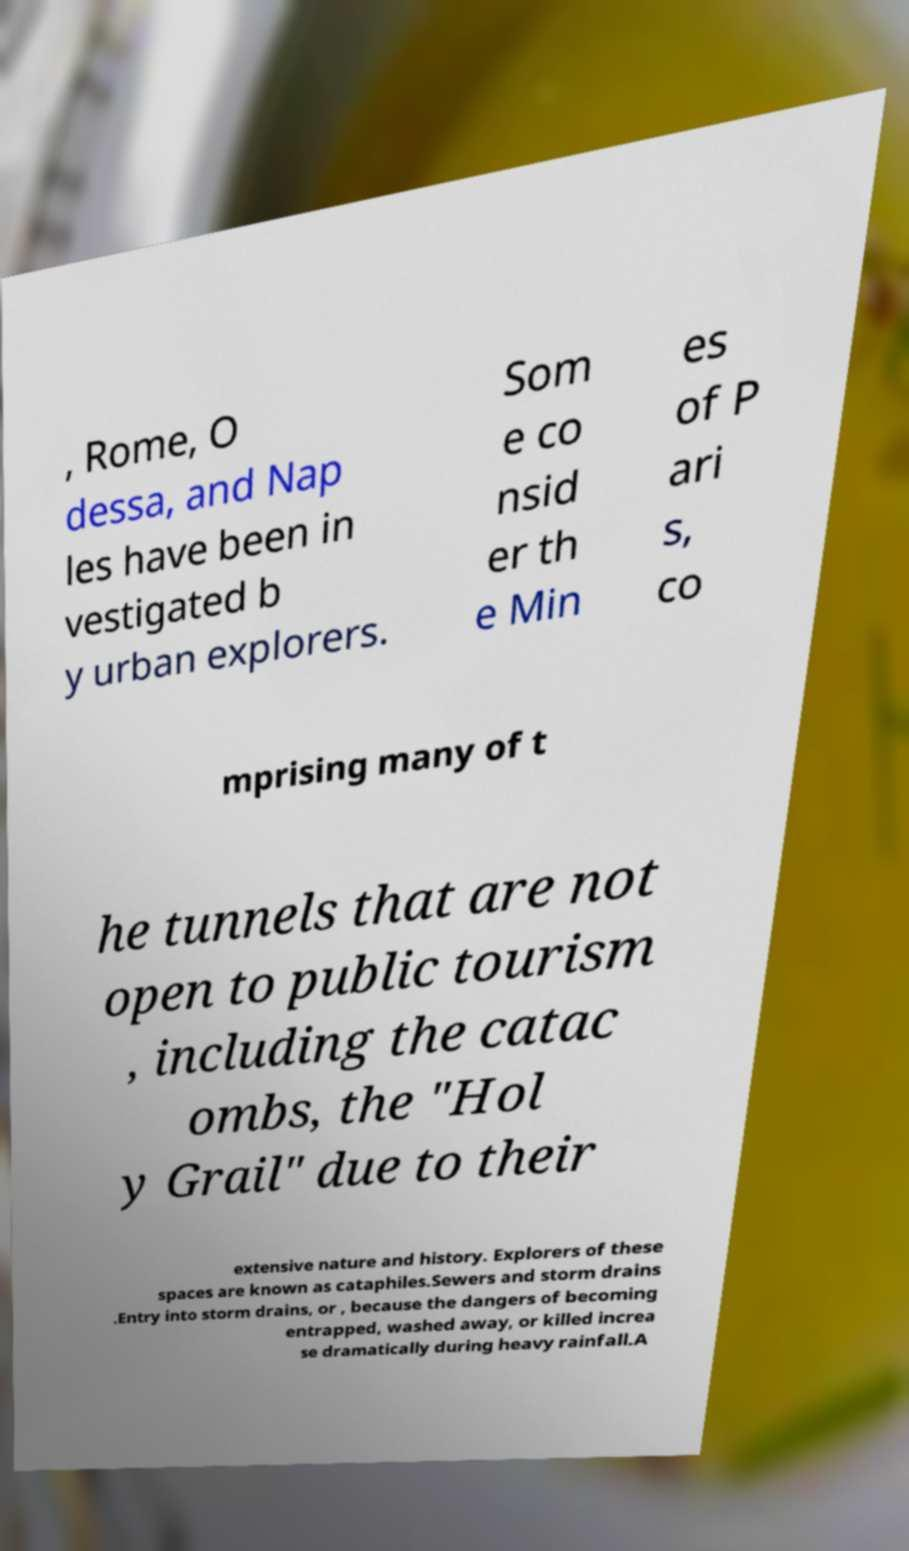Please read and relay the text visible in this image. What does it say? , Rome, O dessa, and Nap les have been in vestigated b y urban explorers. Som e co nsid er th e Min es of P ari s, co mprising many of t he tunnels that are not open to public tourism , including the catac ombs, the "Hol y Grail" due to their extensive nature and history. Explorers of these spaces are known as cataphiles.Sewers and storm drains .Entry into storm drains, or , because the dangers of becoming entrapped, washed away, or killed increa se dramatically during heavy rainfall.A 